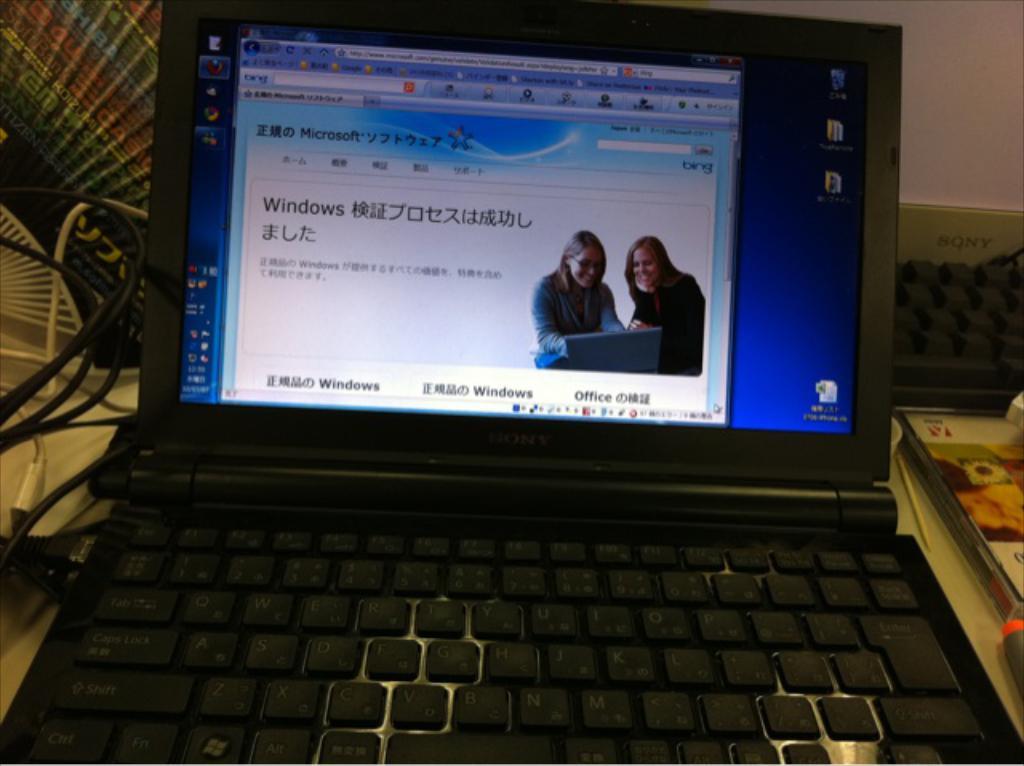What company is mentioned on this website?
Offer a terse response. Microsoft. What software suite is shown on the bottom right of the screen?
Provide a short and direct response. Office. 